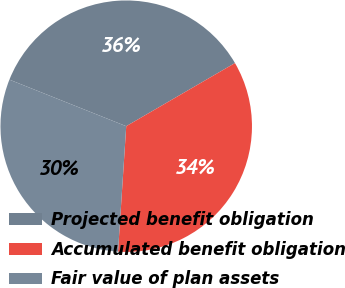Convert chart to OTSL. <chart><loc_0><loc_0><loc_500><loc_500><pie_chart><fcel>Projected benefit obligation<fcel>Accumulated benefit obligation<fcel>Fair value of plan assets<nl><fcel>35.59%<fcel>34.41%<fcel>30.0%<nl></chart> 